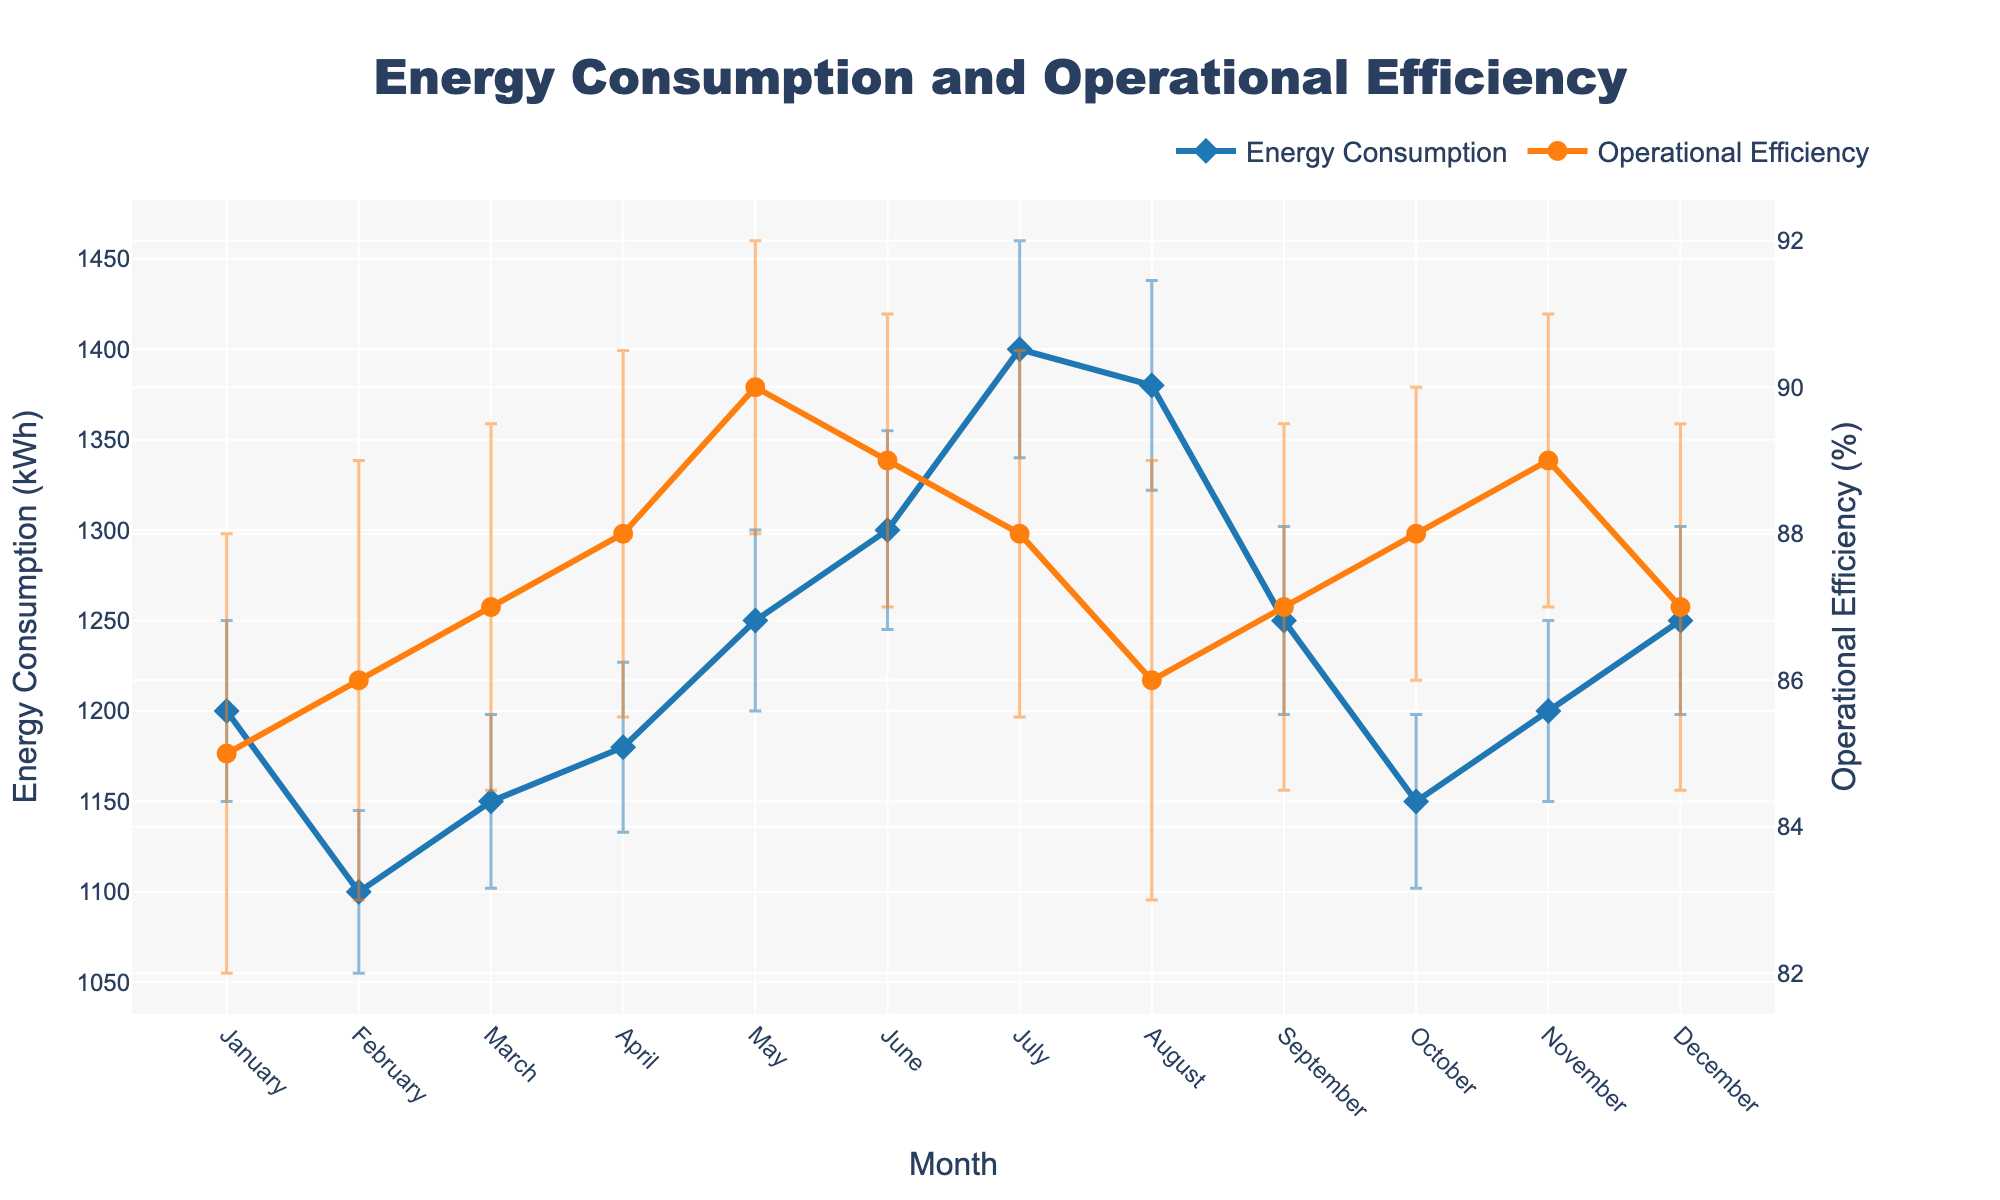What's the title of the figure? The title of the figure is displayed at the top center and usually describes the overall theme of the chart.
Answer: Energy Consumption and Operational Efficiency What is the highest energy consumption recorded, and in which month? Look at the peaks of the blue line representing energy consumption and note the corresponding month. The highest value is in July.
Answer: 1400 kWh, July What is the lowest operational efficiency recorded and in which month? Identify the lowest point of the orange line representing operational efficiency and trace it to the corresponding month. The lowest value occurs in February and August.
Answer: 86%, February and August How does energy consumption in January compare to December? Look at the values for energy consumption at both ends of the blue line for January and December and compare them. Both January and December consume the same energy.
Answer: They are the same, 1200 kWh What is the average operational efficiency over the entire year? Add up the operational efficiency percentages for all months and divide by the number of months (12). (85+86+87+88+90+89+88+86+87+88+89+87)/12
Answer: 87.3% During which month does both energy consumption and operational efficiency have the lowest error bars? Examine the error bars for each line and identify the month with the shortest bars for both energy consumption and operational efficiency. March shows the lowest errors for both.
Answer: March Which month shows the largest discrepancy between energy consumption and operational efficiency? Find the month where the difference between the energy consumption (kWh) and operational efficiency (%) seems the largest. July has the largest discrepancy.
Answer: July What is the range of energy consumption in kWh over the year? Determine the difference between the highest and lowest recorded energy consumption values. The highest is 1400 kWh in July and the lowest is 1100 kWh in February.
Answer: 300 kWh Which month saw a decrease in operational efficiency but an increase in energy consumption compared to the previous month? Compare the consecutive months for an increase in energy consumption and a decrease in operational efficiency. This trend is visible between May and June.
Answer: June How does the operational efficiency in April compare to that in October? Compare the operational efficiency percentages for April and October. Both percentages are equal.
Answer: They are the same, 88% 